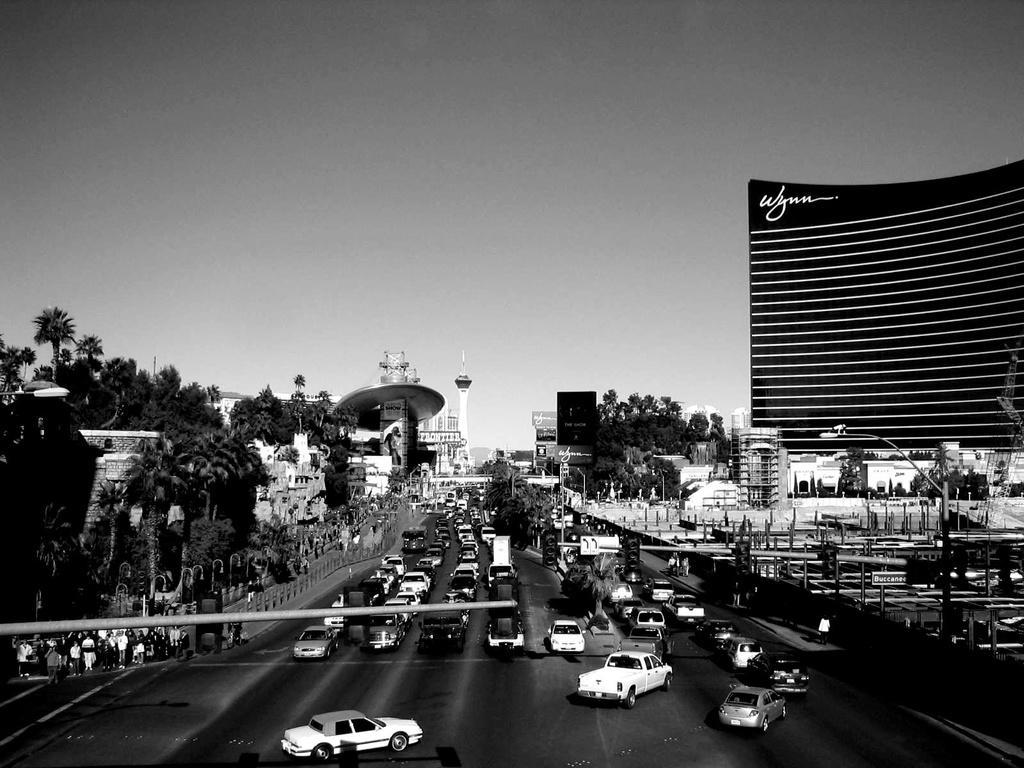Please provide a concise description of this image. In the foreground I can see fleets of cars, crowd, fence, trees and light poles on the road. In the background I can see buildings, boards and so on. At the top I can see the sky. This image is taken may be on the road. 